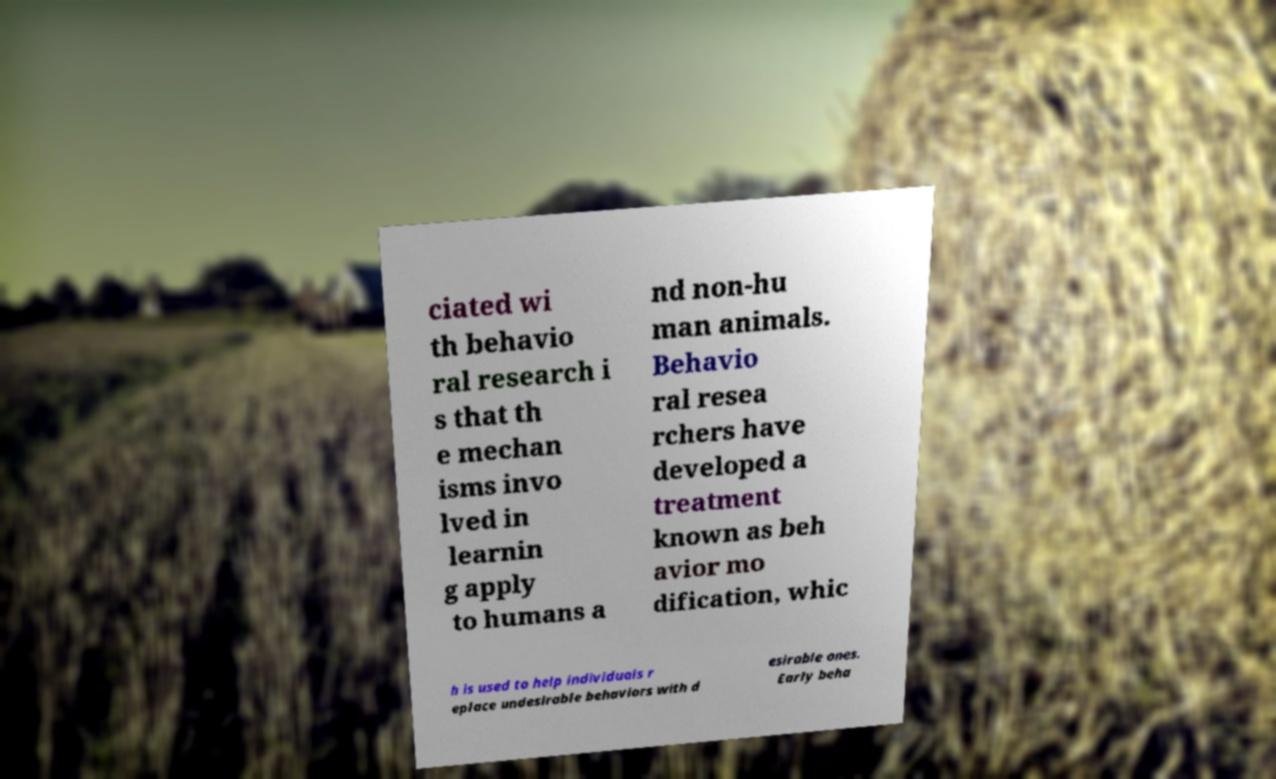Can you accurately transcribe the text from the provided image for me? ciated wi th behavio ral research i s that th e mechan isms invo lved in learnin g apply to humans a nd non-hu man animals. Behavio ral resea rchers have developed a treatment known as beh avior mo dification, whic h is used to help individuals r eplace undesirable behaviors with d esirable ones. Early beha 